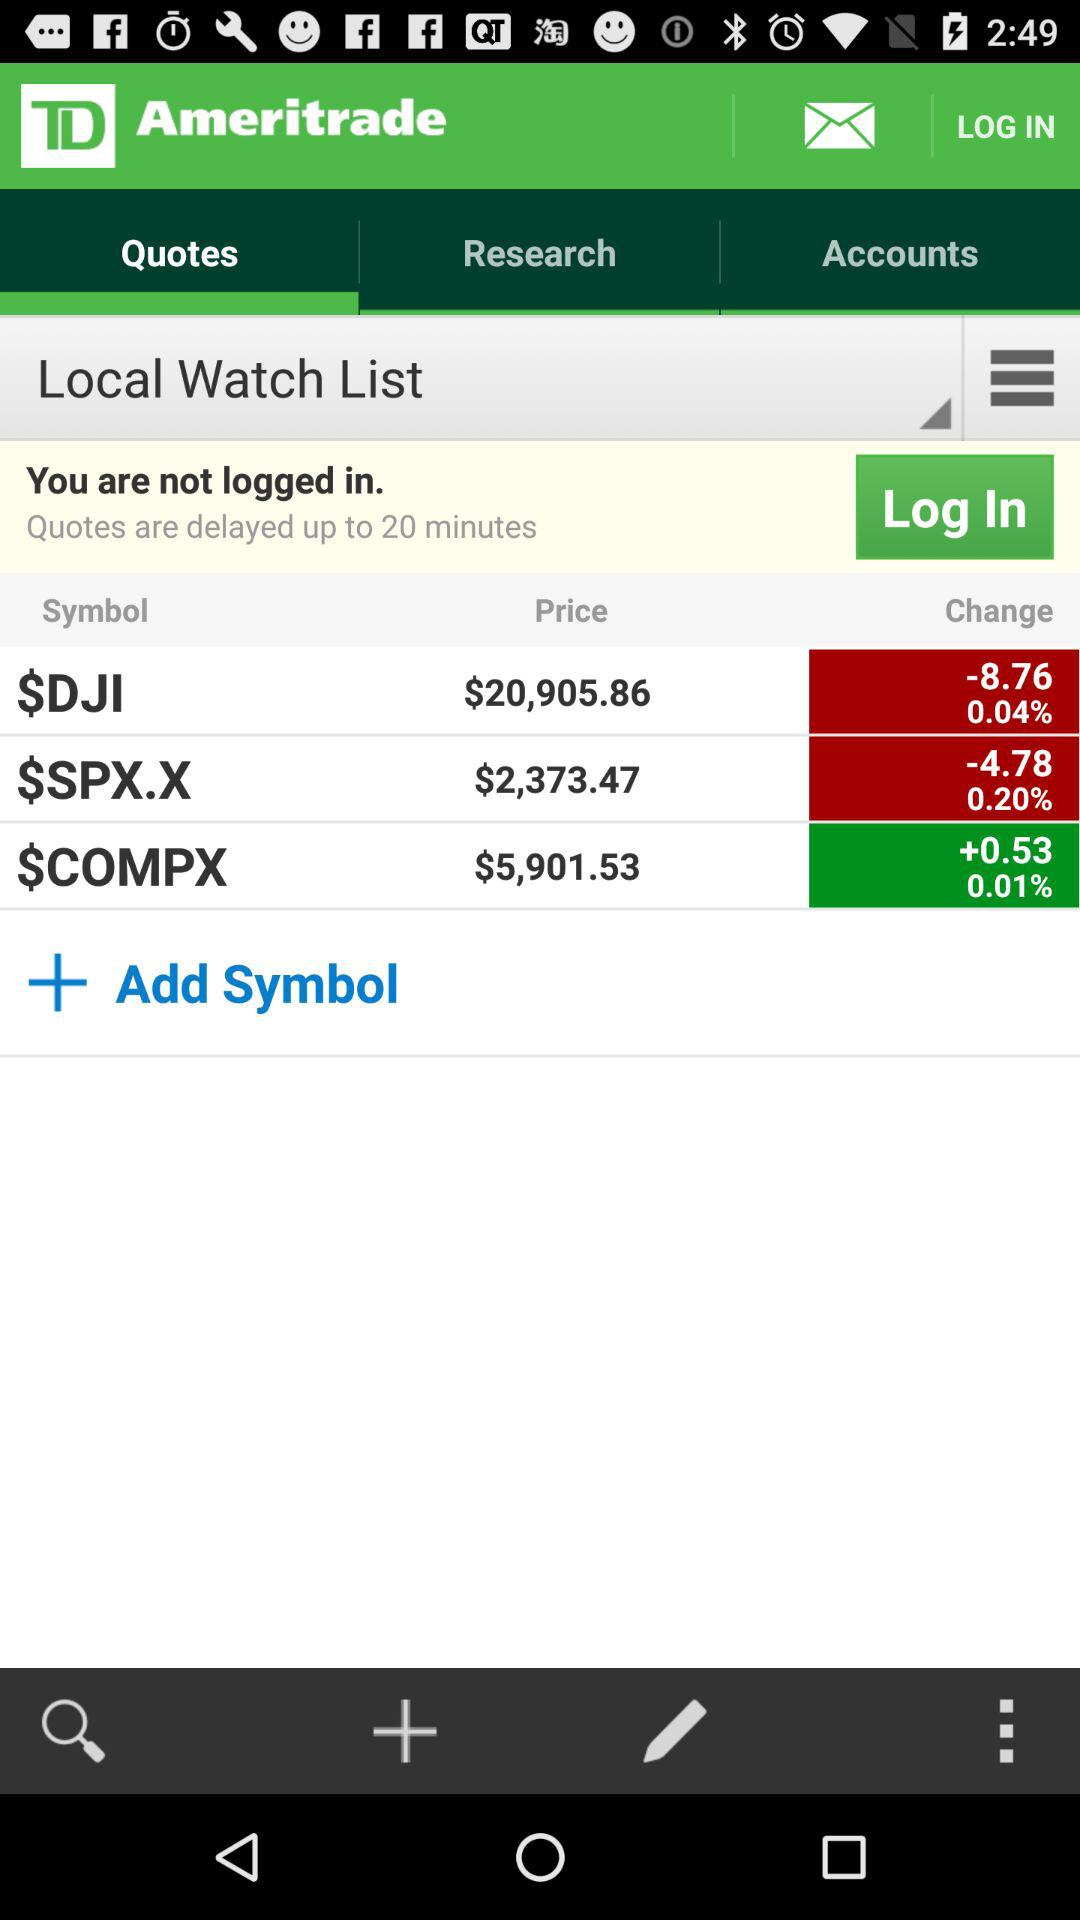How much is the percentage change in $COMPX? The percentage change is 0.01%. 